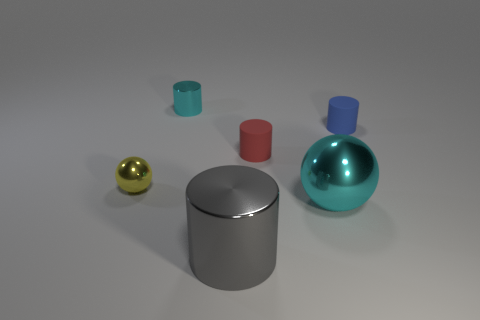Add 4 cyan metal things. How many objects exist? 10 Subtract all cylinders. How many objects are left? 2 Subtract 0 yellow blocks. How many objects are left? 6 Subtract all big blue cylinders. Subtract all yellow metallic spheres. How many objects are left? 5 Add 2 tiny cylinders. How many tiny cylinders are left? 5 Add 2 small yellow spheres. How many small yellow spheres exist? 3 